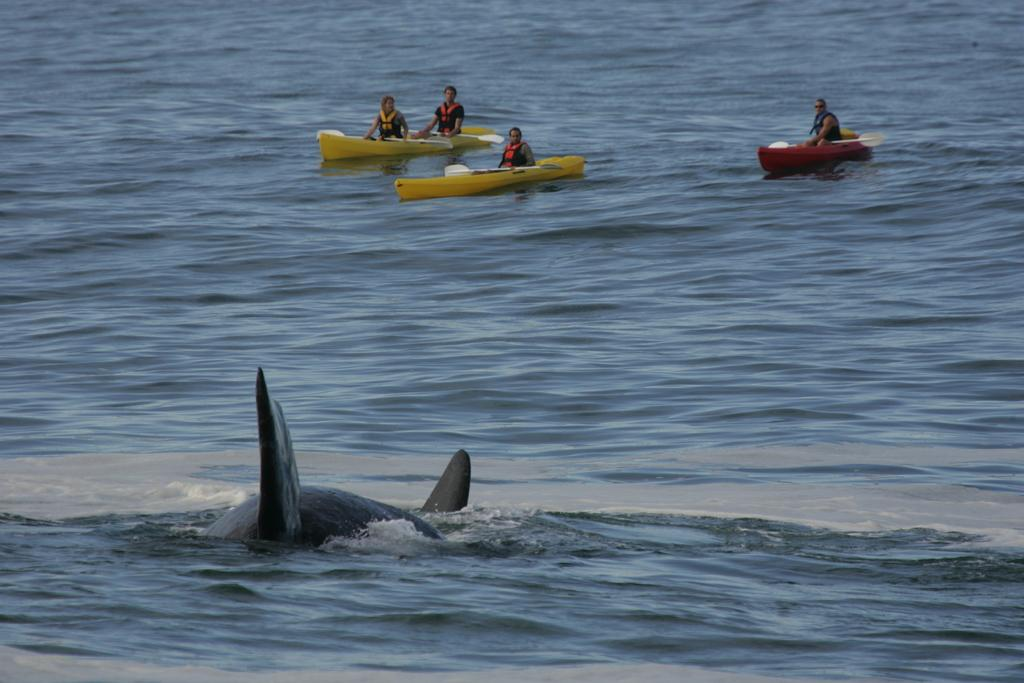What type of water is depicted in the image? The image contains water that appears to be an ocean. Can you describe any marine life visible in the image? Yes, there is a fish visible at the bottom of the image. What are the people in the image doing? The people are sitting on boats in the background of the image. Where is the coal mine located in the image? There is no coal mine present in the image; it features an ocean with a fish and people on boats. What type of pump can be seen operating in the image? There is no pump visible in the image. 